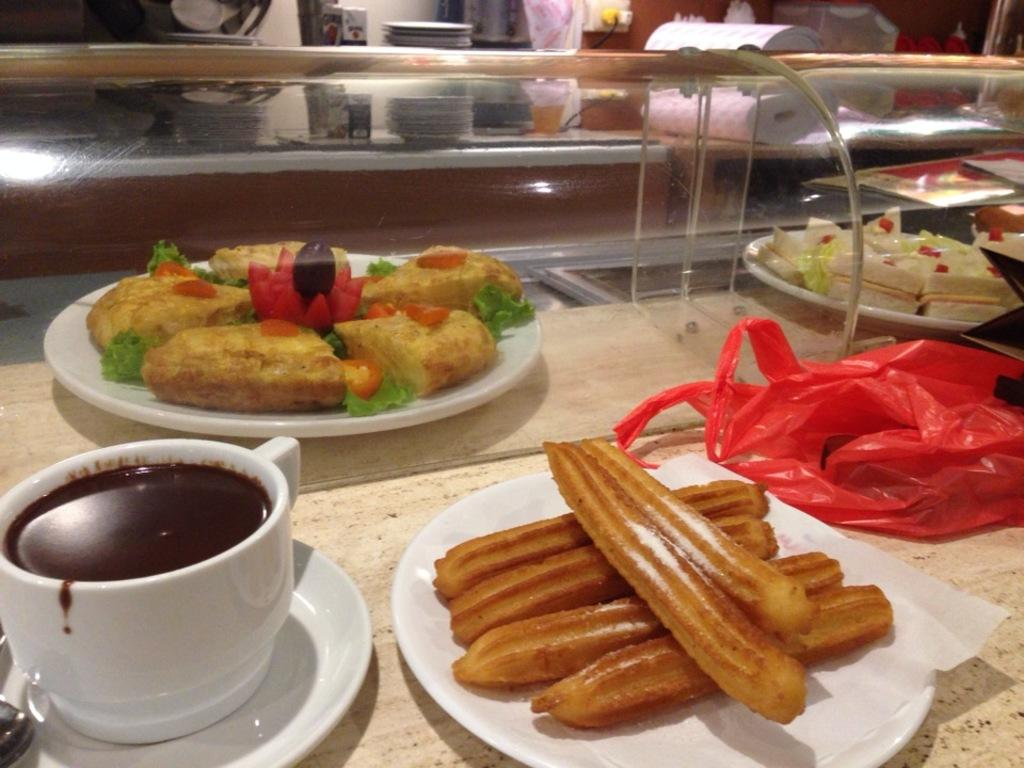What type of dishware can be seen in the image? There are plates and a saucer with a cup in the image. What utensil is present in the image? There is a spoon in the image. What is being served on the plates? There are food items in the image. On what surface are the plates and food items placed? There is an object on which the food items are placed. What type of glass object is visible behind the plates? There is a glass object behind the plates. Can you describe any other unspecified items visible in the image? Unfortunately, the provided facts do not specify any other items visible in the image. What type of record is being played on the turntable in the image? There is no turntable or record present in the image. Can you describe the secretary's attire in the image? There is no secretary present in the image. 